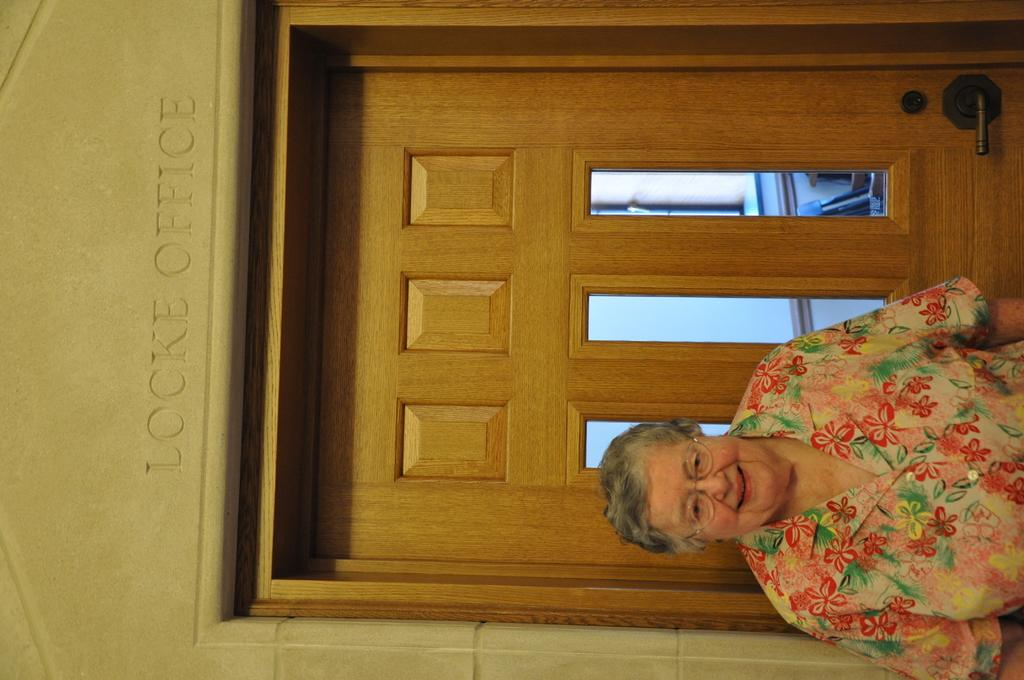Who is present in the image? There is a woman in the image. What is the woman doing in the image? The woman is standing in front of a closed door. How is the woman's facial expression in the image? The woman has a smile on her face. What can be seen above the door in the image? There is text engraved on the wall above the door. What type of friction is the woman experiencing while standing in front of the door? There is no information about friction in the image, as it does not involve any physical interaction between the woman and the door. 